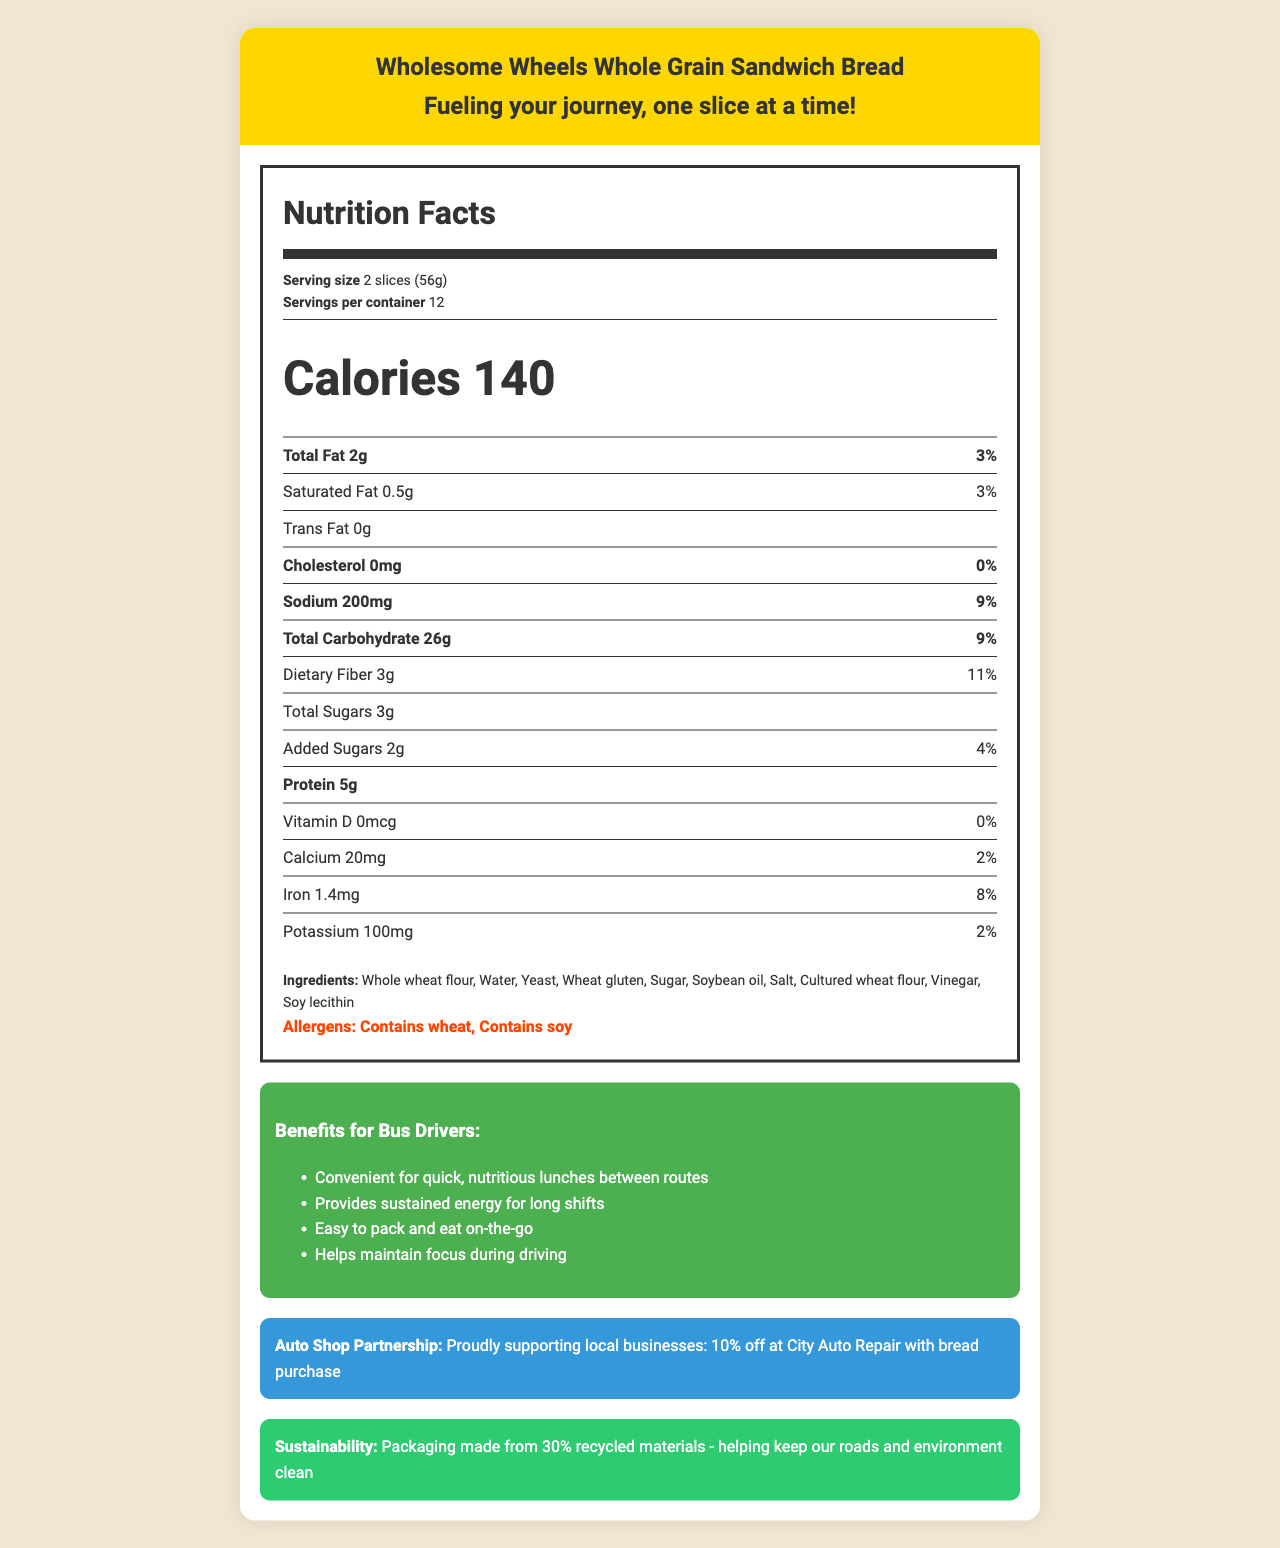what is the serving size? The serving size is specified at the beginning of the Nutrition Facts section as "2 slices (56g)."
Answer: 2 slices (56g) how many calories are in a serving? The number of calories per serving is listed as "Calories 140."
Answer: 140 what is the total fat content per serving? The total fat content per serving is specified as "Total Fat 2g."
Answer: 2g What is the daily value percentage of dietary fiber per serving? The daily value percentage of dietary fiber per serving is noted as "Dietary Fiber 11%."
Answer: 11% What are the allergens present in this bread? The allergens are listed at the bottom of the nutrition section as "Contains wheat" and "Contains soy."
Answer: Contains wheat, Contains soy How many grams of protein are in one serving? The protein content per serving is listed as "Protein 5g."
Answer: 5g What is the main ingredient in this bread? The first ingredient listed is "Whole wheat flour," indicating it is the main ingredient.
Answer: Whole wheat flour How many servings are in the entire container? The document specifies that there are "Servings per container: 12."
Answer: 12 Which of the following ingredients is not present in the bread? A. Soy lecithin B. Vinegar C. Milk D. Cultured wheat flour Milk is not listed among the ingredients provided in the document, whereas the others are.
Answer: C. Milk What is the cholesterol content per serving? A. 0mg B. 5mg C. 20mg D. 10mg The document specifies "Cholesterol 0mg."
Answer: A. 0mg True or False: This bread contains no trans fat. The document lists "Trans Fat 0g," indicating it contains no trans fat.
Answer: True Summarize the main details provided by the nutrition label of Wholesome Wheels Whole Grain Sandwich Bread. The summary captures the key elements like serving size, calorie count, fat content, sodium, carbohydrates, sugars, protein, ingredients, allergens, and additional notes on benefits, partnerships, and sustainability.
Answer: Wholesome Wheels Whole Grain Sandwich Bread offers detailed nutrition information per serving, which is 2 slices (56g). Each serving contains 140 calories, 2g of total fat, 0.5g of saturated fat, and 0g of trans fat. The cholesterol content is 0mg, while sodium is 200mg. Carbohydrates total 26g, including 3g of dietary fiber and 3g of total sugars, of which 2g are added sugars. There is also 5g of protein. The bread is made from ingredients such as whole wheat flour, yeast, and soy lecithin and contains allergens like wheat and soy. Special notes highlight benefits for bus drivers, an auto shop partnership, and sustainability efforts. How much iron is in one serving of this bread? The document specifies "Iron 1.4mg" for one serving of the bread.
Answer: 1.4mg Can we find the price of the bread from this document? The document does not provide any information about the price of the bread.
Answer: Not enough information 